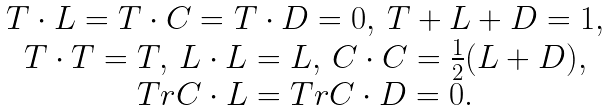<formula> <loc_0><loc_0><loc_500><loc_500>\begin{array} [ c ] { c } T \cdot L = T \cdot C = T \cdot D = 0 , \, T + L + D = 1 , \\ T \cdot T = T , \, L \cdot L = L , \, C \cdot C = \frac { 1 } { 2 } ( L + D ) , \\ T r C \cdot L = T r C \cdot D = 0 . \end{array}</formula> 